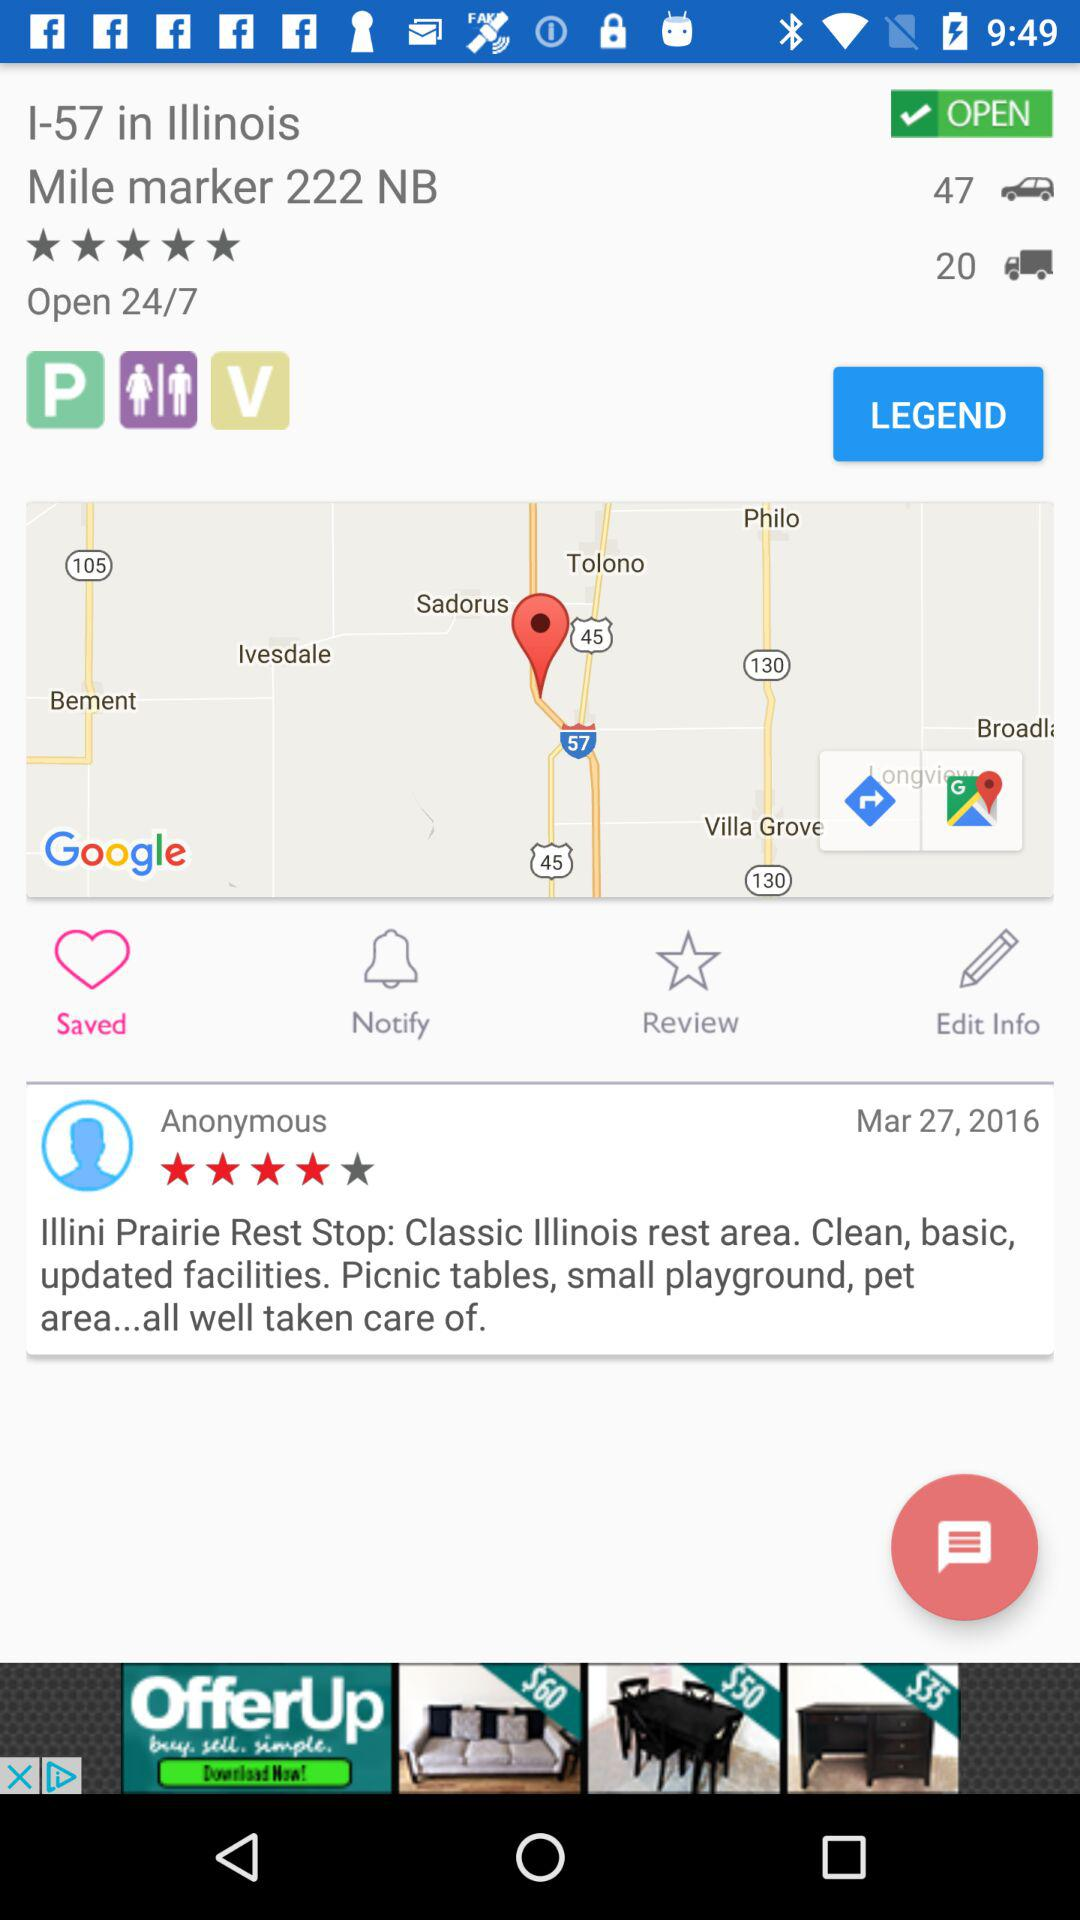What date is reflected on the screen? The reflected date is March 27, 2016. 